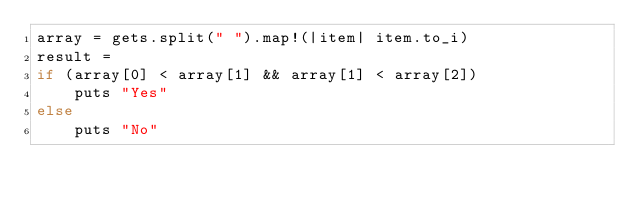Convert code to text. <code><loc_0><loc_0><loc_500><loc_500><_Ruby_>array = gets.split(" ").map!(|item| item.to_i)
result = 
if (array[0] < array[1] && array[1] < array[2]) 
    puts "Yes"
else
    puts "No"</code> 